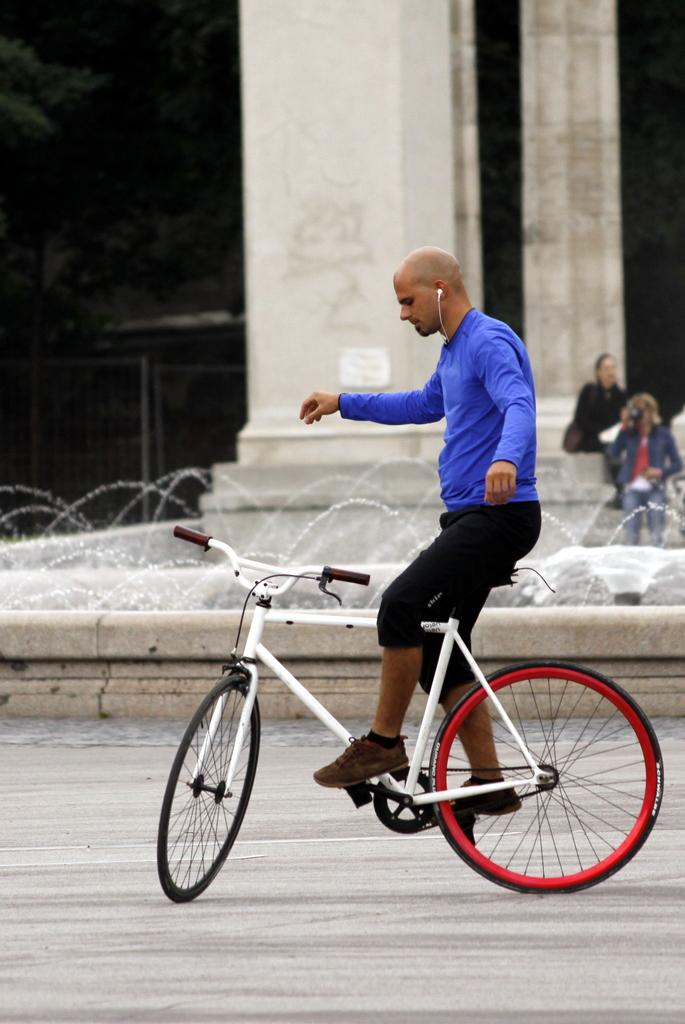What is the man in the image doing? The man is on a bicycle in the image. What can be seen in the background of the image? There is a road in the image. What object is present in the image that might be used for support or structure? There is a pillar in the image. How many people are visible in the image? There are two persons visible in the image. What grade did the man on the bicycle receive in his treatment? There is no mention of treatment or grades in the image, as it features a man on a bicycle, a road, a pillar, and two persons. 